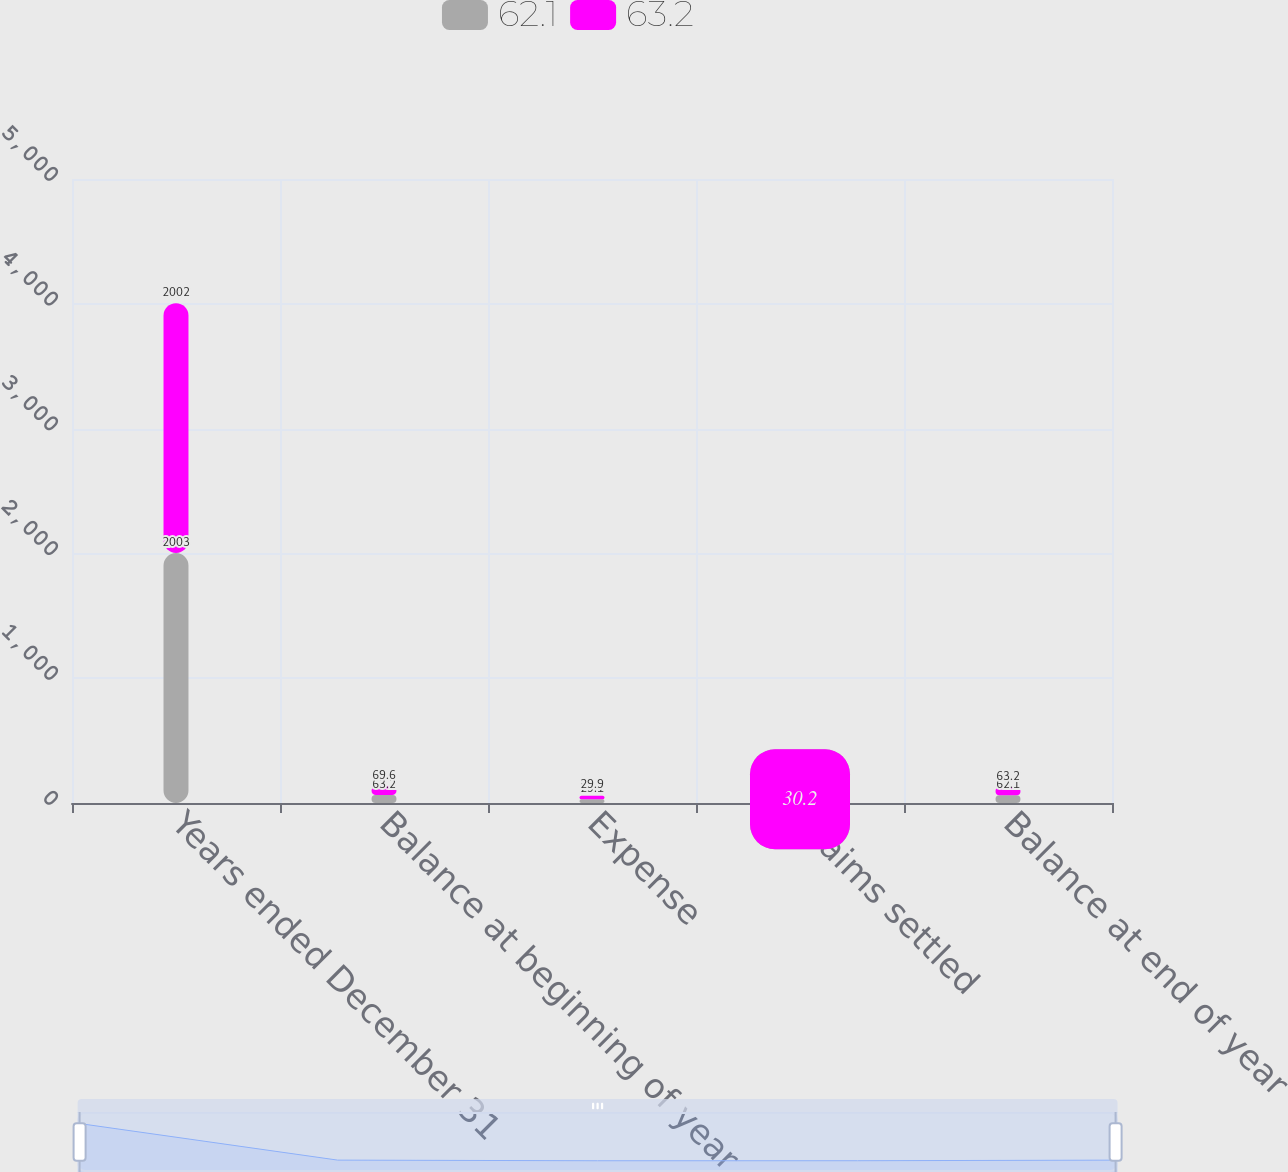Convert chart to OTSL. <chart><loc_0><loc_0><loc_500><loc_500><stacked_bar_chart><ecel><fcel>Years ended December 31<fcel>Balance at beginning of year<fcel>Expense<fcel>Claims settled<fcel>Balance at end of year<nl><fcel>62.1<fcel>2003<fcel>63.2<fcel>29.1<fcel>30.2<fcel>62.1<nl><fcel>63.2<fcel>2002<fcel>69.6<fcel>29.9<fcel>29.1<fcel>63.2<nl></chart> 